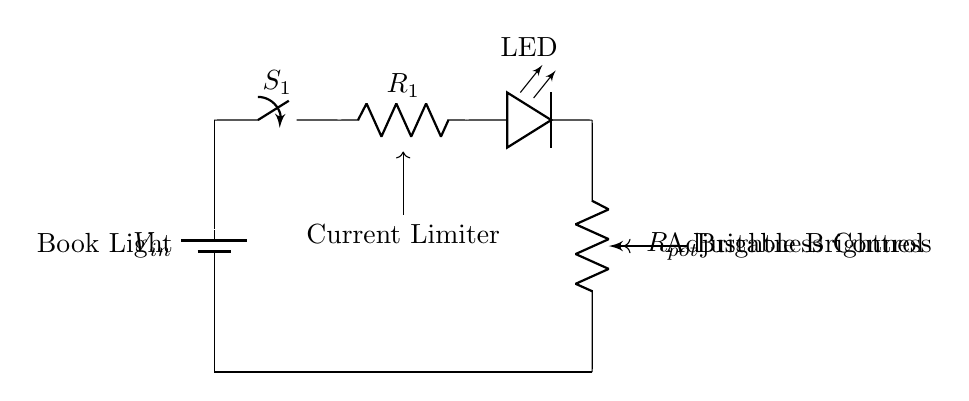What component limits the current in this circuit? The current-limiting resistor, labeled as R1, is the component that restricts the amount of current flowing through the circuit, protecting the LED from excessive current that could damage it.
Answer: R1 What does the switch S1 control? The switch S1 controls the on/off state of the circuit, allowing or interrupting the flow of electricity from the battery to the rest of the components when the switch is flipped.
Answer: On/off state What is the purpose of the potentiometer labeled Rpot? The potentiometer Rpot serves as a variable resistor that allows the brightness of the LED to be adjusted by changing the resistance, which in turn affects the current flowing through the LED.
Answer: Brightness adjustment How many components are involved in this circuit? The circuit includes a battery, switch, current-limiting resistor, LED, and potentiometer, totaling five components.
Answer: Five If the LED is glowing dimly, what might be the reason? If the LED is glowing dimly, it could be due to a high resistance value set by the potentiometer Rpot, therefore reducing the current flowing through the LED, or it could be connected improperly with insufficient voltage.
Answer: High resistance What type of circuit design is this? This is a low-power LED circuit used for lighting purposes, specifically designed for a book light that features adjustable brightness.
Answer: Low-power LED circuit 